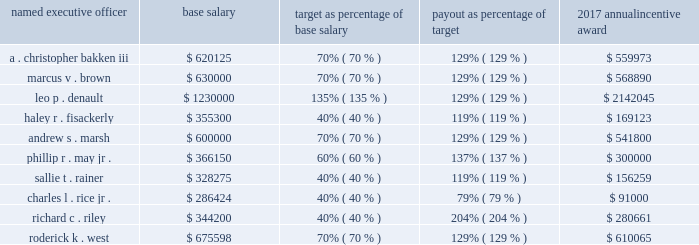Based on the foregoing evaluation of management performance , the personnel committee approved the following annual incentive plan payouts to each named executive officer for 2017 : named executive officer base salary target as percentage of base salary payout as percentage of target 2017 annual incentive award .
Nuclear retention plan mr . a0bakken participates in the nuclear retention plan , a retention plan for officers and other leaders with expertise in the nuclear industry .
The personnel committee authorized this plan to attract and retain key management and employee talent in the nuclear power field , a field that requires unique technical and other expertise that is in great demand in the utility industry .
The plan provides for bonuses to be paid annually over a three-year employment period with the bonus opportunity dependent on the participant 2019s management level and continued employment .
Each annual payment is equal to an amount ranging from 15% ( 15 % ) to 30% ( 30 % ) of the employee 2019s base salary as of their date of enrollment in the plan .
Mr . a0bakken 2019s participation in the plan commenced in may 2016 and in accordance with the terms and conditions of the plan , in may 2017 , 2018 , and 2019 , subject to his continued employment , mr . a0bakken will receive a cash bonus equal to 30% ( 30 % ) of his base salary as of may a01 , 2016 .
This plan does not allow for accelerated or prorated payout upon termination of any kind .
The three-year coverage period and percentage of base salary payable under the plan are consistent with the terms of participation of other senior nuclear officers who participate in this plan .
In may 2017 , mr .
Bakken received a cash bonus of $ 181500 which equaled 30% ( 30 % ) of his may a01 , 2016 , base salary of $ 605000 .
Long-term incentive compensation entergy corporation 2019s goal for its long-term incentive compensation is to focus the executive officers on building shareholder value and to increase the executive officers 2019 ownership of entergy corporation 2019s common stock in order to more closely align their interest with those of entergy corporation 2019s shareholders .
In its long-term incentive compensation programs , entergy corporation uses a mix of performance units , restricted stock , and stock options .
Performance units are used to deliver more than a majority of the total target long-term incentive awards .
For periods through the end of 2017 , performance units reward the named executive officers on the basis of total shareholder return , which is a measure of stock price appreciation and dividend payments , in relation to the companies in the philadelphia utility index .
Beginning with the 2018-2020 performance period , a cumulative utility earnings metric has been added to the long-term performance unit program to supplement the relative total shareholder return measure that historically has been used in this program with each measure equally weighted .
Restricted stock ties the executive officers 2019 long-term financial interest to the long-term financial interests of entergy corporation 2019s shareholders .
Stock options provide a direct incentive to increase the value of entergy corporation 2019s common stock .
In general , entergy corporation seeks to allocate the total value of long-term incentive compensation 60% ( 60 % ) to performance units and 40% ( 40 % ) to a combination of stock options and restricted stock , equally divided in value , based on the value the compensation model seeks to deliver .
Awards for individual named executive officers may vary from this target as a result of individual performance , promotions , and internal pay equity .
The performance units for the 2015-2017 performance period were awarded under the 2011 equity ownership plan and long-term cash incentive plan ( the 201c2011 equity ownership plan 201d ) and the performance units for the .
What is the difference between the highest and the lowest base salary? 
Computations: (1230000 - 286424)
Answer: 943576.0. 